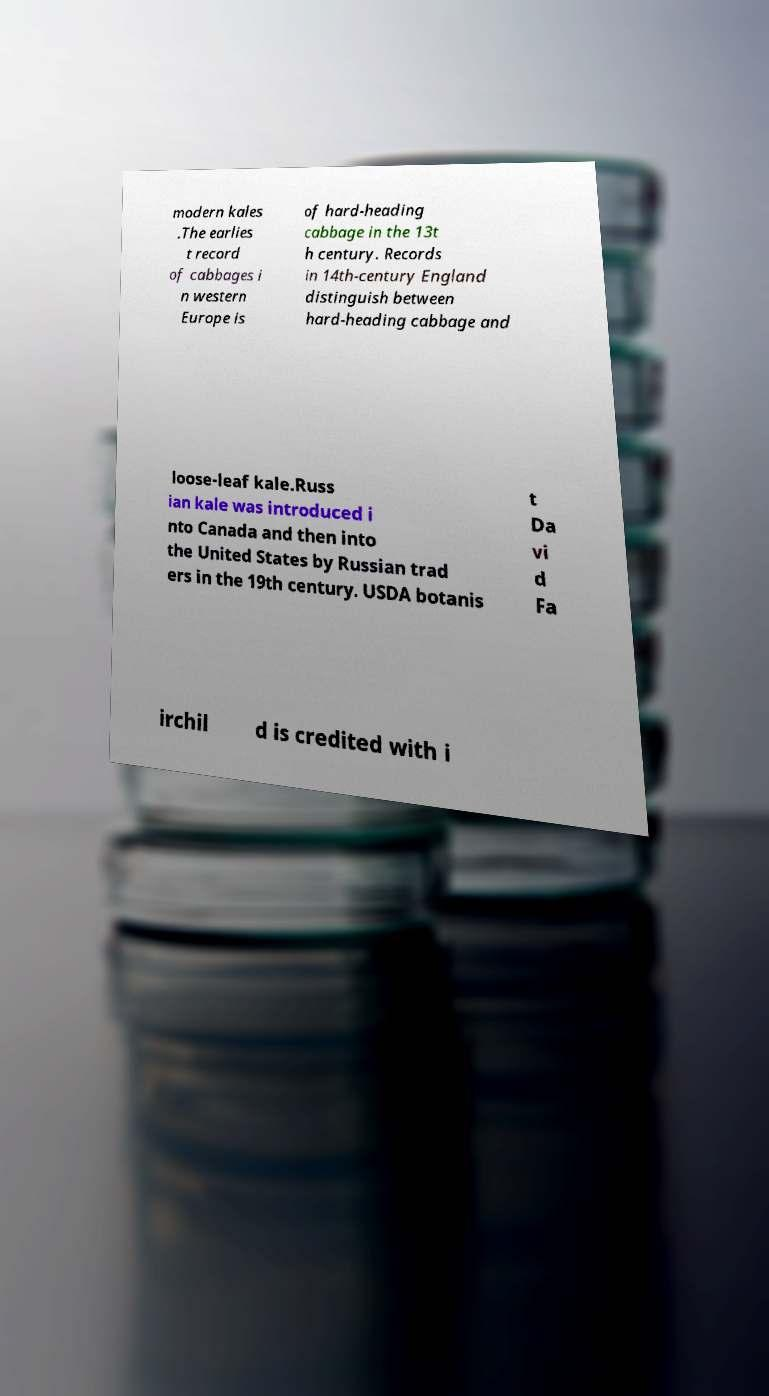For documentation purposes, I need the text within this image transcribed. Could you provide that? modern kales .The earlies t record of cabbages i n western Europe is of hard-heading cabbage in the 13t h century. Records in 14th-century England distinguish between hard-heading cabbage and loose-leaf kale.Russ ian kale was introduced i nto Canada and then into the United States by Russian trad ers in the 19th century. USDA botanis t Da vi d Fa irchil d is credited with i 